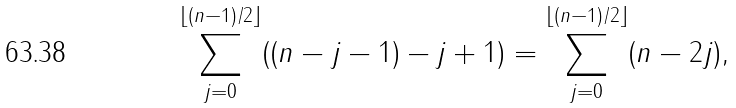Convert formula to latex. <formula><loc_0><loc_0><loc_500><loc_500>\sum _ { j = 0 } ^ { \left \lfloor ( n - 1 ) / 2 \right \rfloor } ( ( n - j - 1 ) - j + 1 ) = \sum _ { j = 0 } ^ { \left \lfloor ( n - 1 ) / 2 \right \rfloor } ( n - 2 j ) ,</formula> 